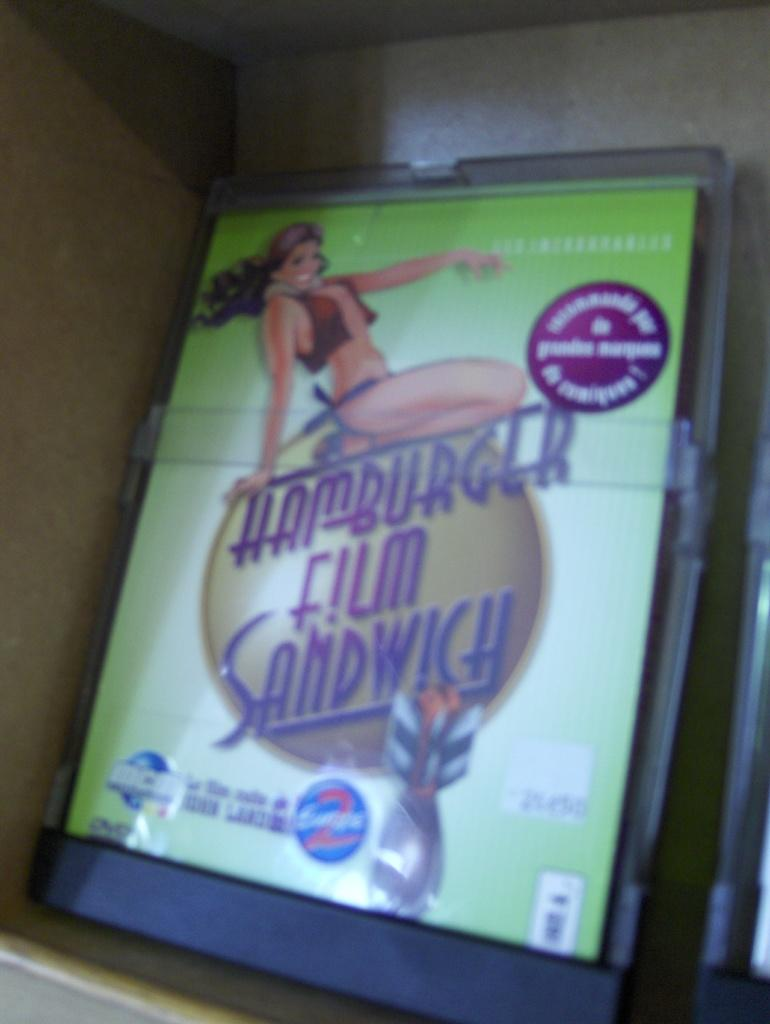What is the main object in the image? There is an advertisement board in the image. What is depicted on the advertisement board? The advertisement board features an animated person. Is there any text on the advertisement board? Yes, there is text written on the advertisement board. What type of ray can be seen swimming in the image? There is no ray present in the image; it features an advertisement board with an animated person and text. 